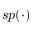<formula> <loc_0><loc_0><loc_500><loc_500>s p ( \cdot )</formula> 